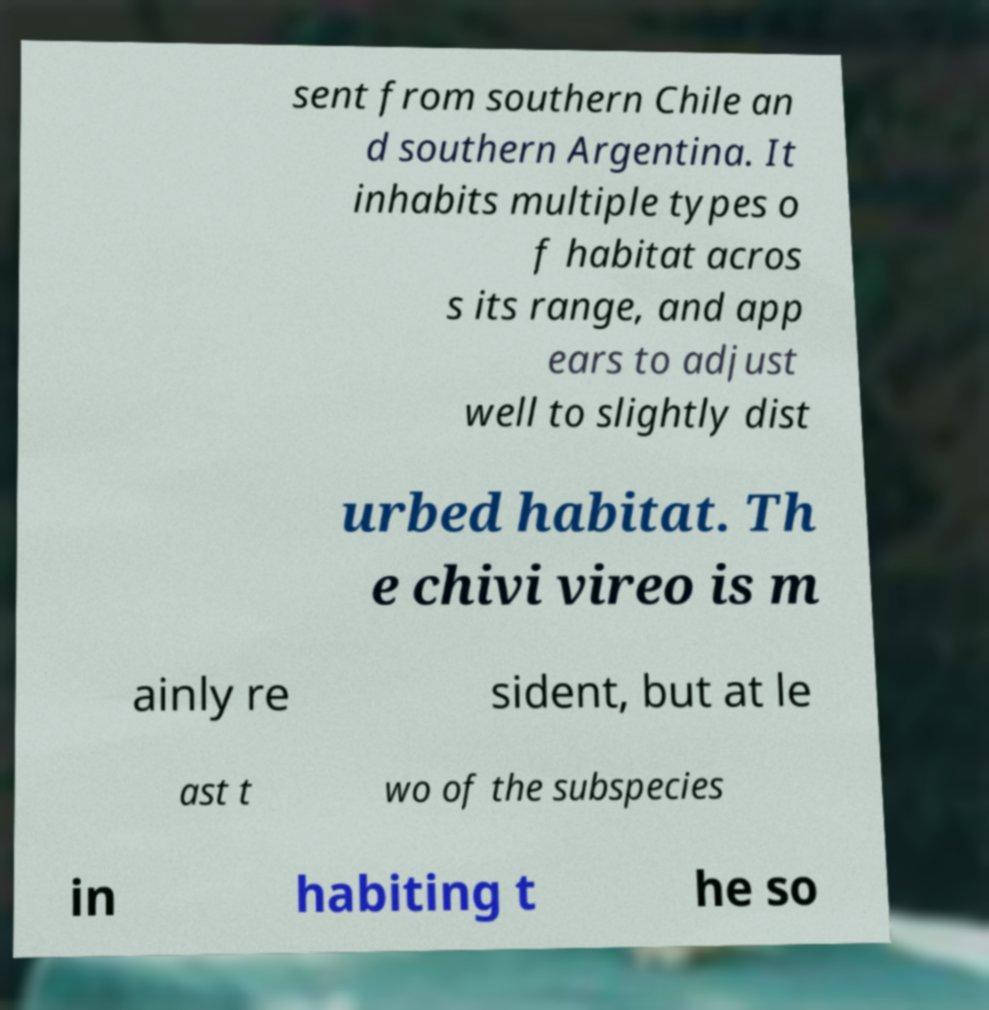There's text embedded in this image that I need extracted. Can you transcribe it verbatim? sent from southern Chile an d southern Argentina. It inhabits multiple types o f habitat acros s its range, and app ears to adjust well to slightly dist urbed habitat. Th e chivi vireo is m ainly re sident, but at le ast t wo of the subspecies in habiting t he so 